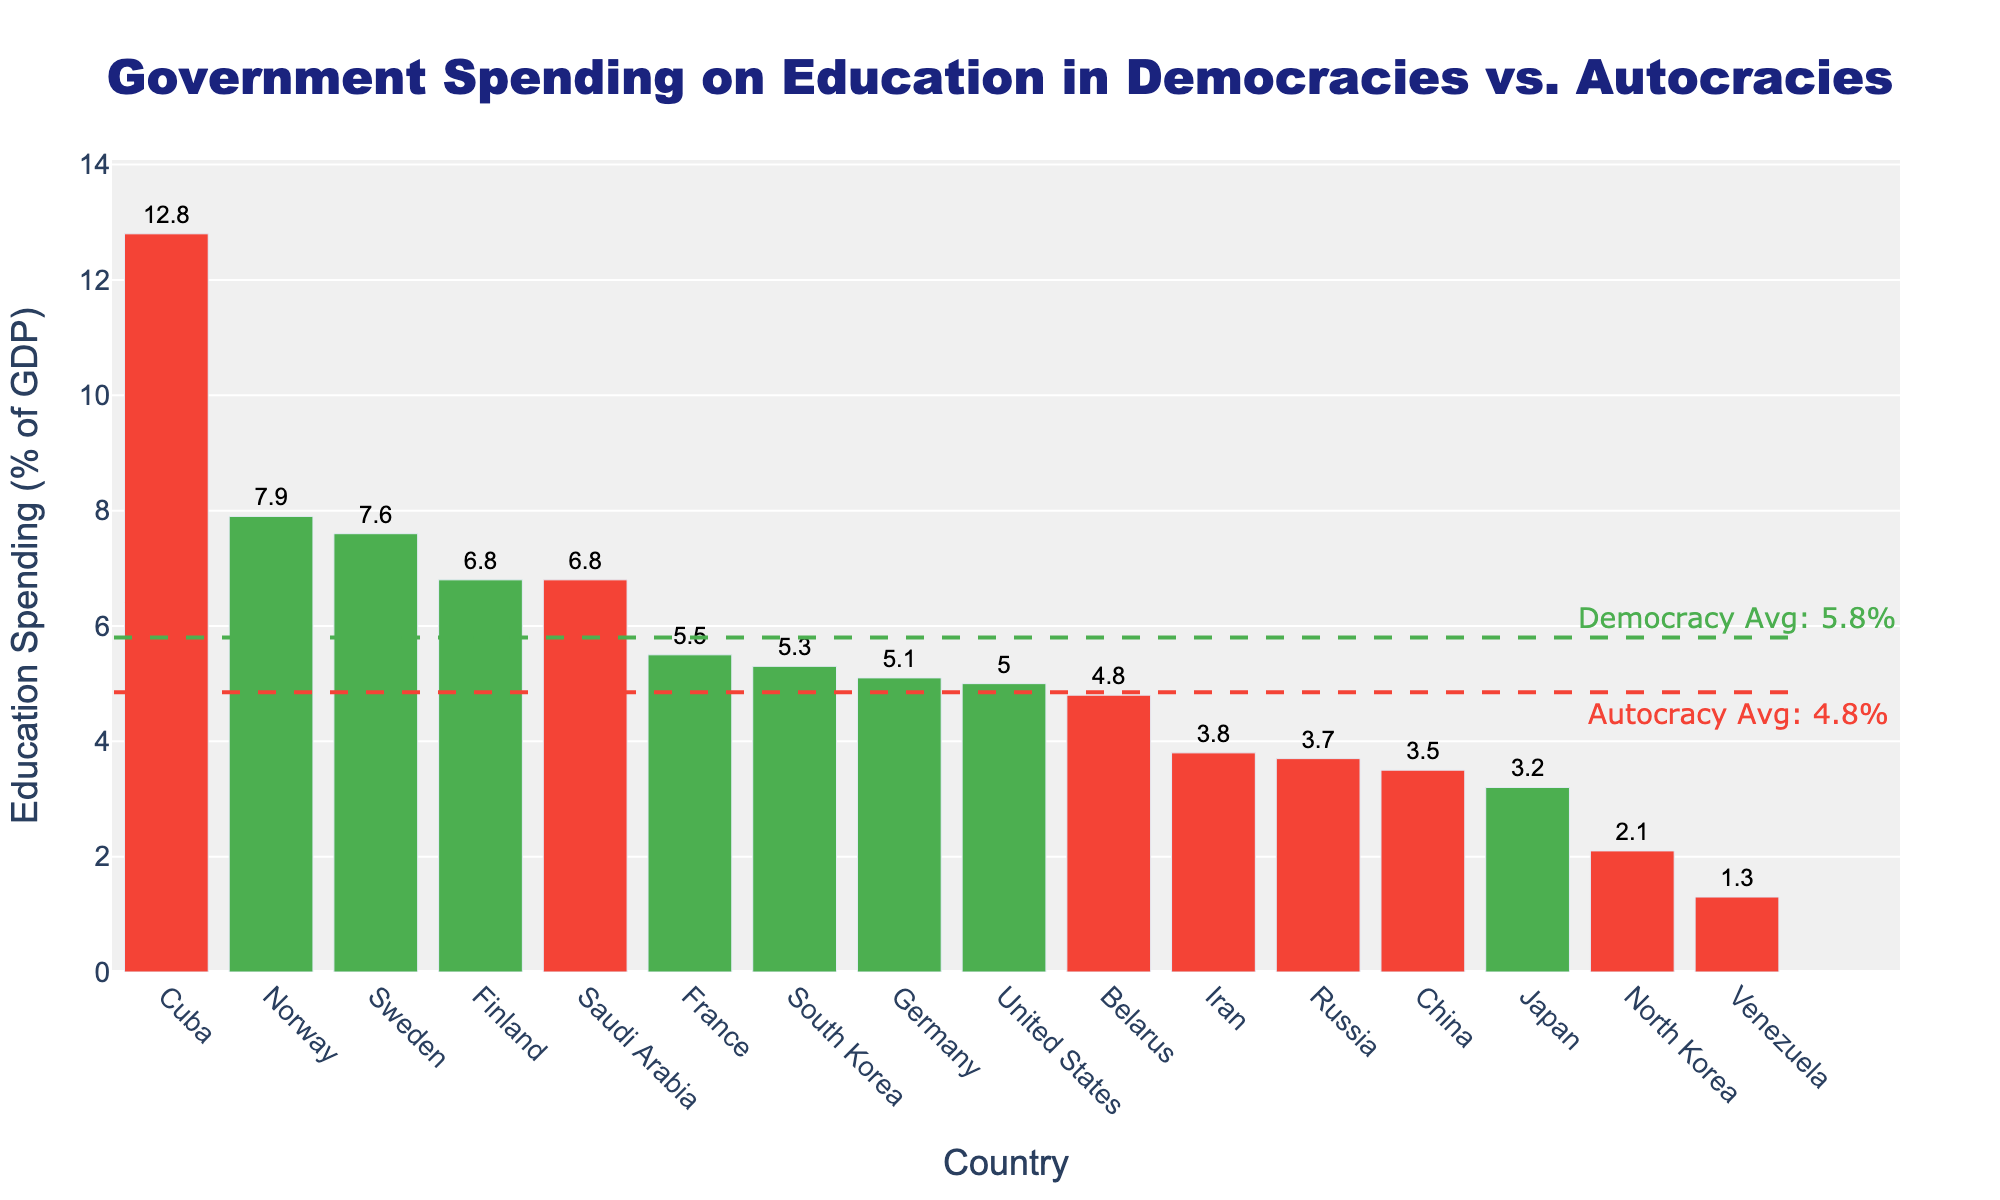What country spends the highest percentage of GDP on education? By visually inspecting the height of the bars, the country with the tallest bar represents the highest spending. From the data, Cuba has the tallest bar with 12.8% of GDP.
Answer: Cuba Which political system, on average, spends more on education? There are average lines for both political systems. The green dashed line (Democracy) is higher than the red dashed line (Autocracy), which means democracies spend more on average.
Answer: Democracies What's the average education spending for democracies and autocracies? The average lines visually indicate the values: The green dashed democracy average line is at 5.3%, and the red dashed autocracy average line is at 4.2%.
Answer: Democracies: 5.3%, Autocracies: 4.2% Which country among democracies spends the least on education? By locating the smallest bar among the green-colored bars, Japan has the shortest bar indicating the lowest spending among democracies at 3.2%.
Answer: Japan Which autocracy has the highest spending on education? By identifying the tallest red-colored bar, Cuba has the highest spending on education with 12.8% of GDP.
Answer: Cuba Compare the education spending of the United States to North Korea. The bar for the United States (5.0%) is taller than the bar for North Korea (2.1%), indicating that the United States spends more on education.
Answer: United States Is there any democracy that spends less on education than China? By comparing the green bars (democracies) to the red bar for China (3.5%), Japan (3.2%) spends less than China.
Answer: Yes, Japan What is the total education spending percentage of the top three spending countries? Adding the spending percentages of the top three countries: Cuba (12.8%), Norway (7.9%), and Sweden (7.6%) gives 12.8 + 7.9 + 7.6 = 28.3%.
Answer: 28.3% Which country has the median spending in education, and what is its value? Sort the countries by spending and find the middle value. There are 16 countries; the median is the average of the 8th and 9th highest spenders. France (5.5%) and South Korea (5.3%) are 8th and 9th, so the median is (5.5 + 5.3)/2 = 5.4%.
Answer: France & South Korea, 5.4% How much more does Norway spend compared to North Korea? Subtract the percentage of North Korea (2.1%) from Norway (7.9%) to find the difference: 7.9 - 2.1 = 5.8%.
Answer: 5.8% 